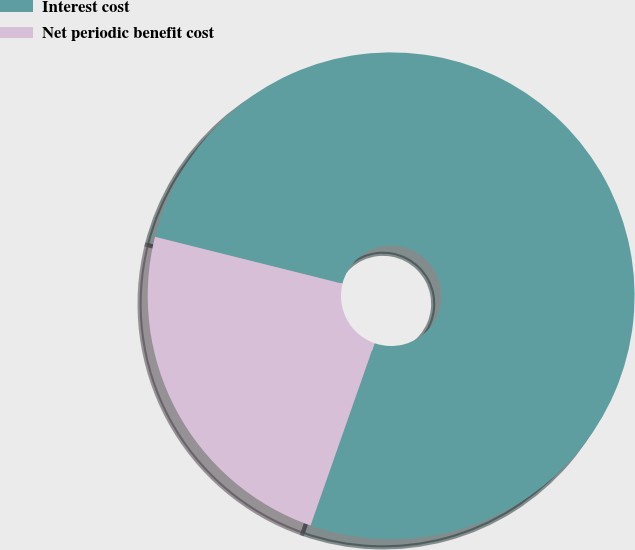<chart> <loc_0><loc_0><loc_500><loc_500><pie_chart><fcel>Interest cost<fcel>Net periodic benefit cost<nl><fcel>76.47%<fcel>23.53%<nl></chart> 